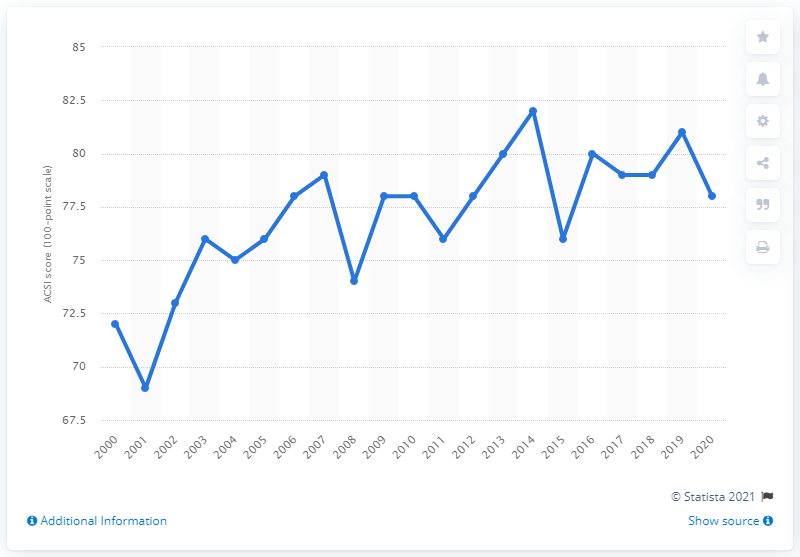Point out several critical features in this image. In 2020, the American Customer Satisfaction Index (ACSI) measured customer satisfaction with internet brokerages at 78 out of 100 possible points. 